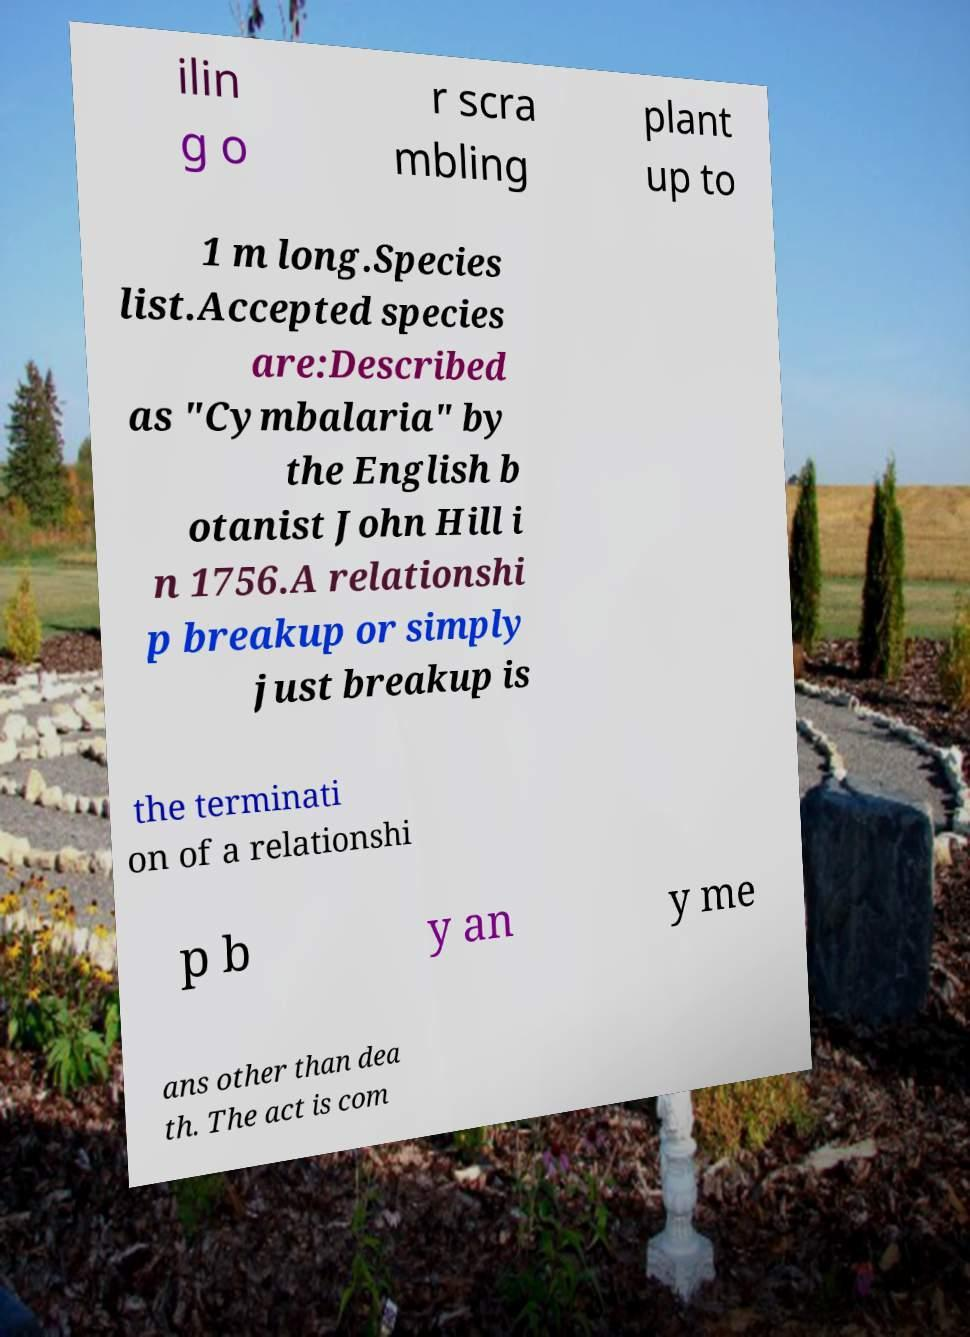There's text embedded in this image that I need extracted. Can you transcribe it verbatim? ilin g o r scra mbling plant up to 1 m long.Species list.Accepted species are:Described as "Cymbalaria" by the English b otanist John Hill i n 1756.A relationshi p breakup or simply just breakup is the terminati on of a relationshi p b y an y me ans other than dea th. The act is com 